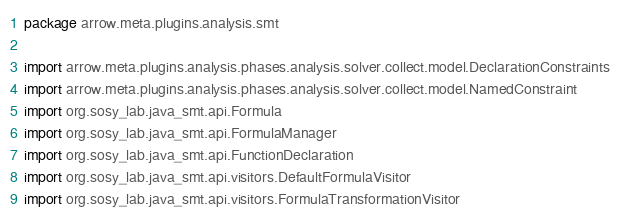Convert code to text. <code><loc_0><loc_0><loc_500><loc_500><_Kotlin_>package arrow.meta.plugins.analysis.smt

import arrow.meta.plugins.analysis.phases.analysis.solver.collect.model.DeclarationConstraints
import arrow.meta.plugins.analysis.phases.analysis.solver.collect.model.NamedConstraint
import org.sosy_lab.java_smt.api.Formula
import org.sosy_lab.java_smt.api.FormulaManager
import org.sosy_lab.java_smt.api.FunctionDeclaration
import org.sosy_lab.java_smt.api.visitors.DefaultFormulaVisitor
import org.sosy_lab.java_smt.api.visitors.FormulaTransformationVisitor</code> 